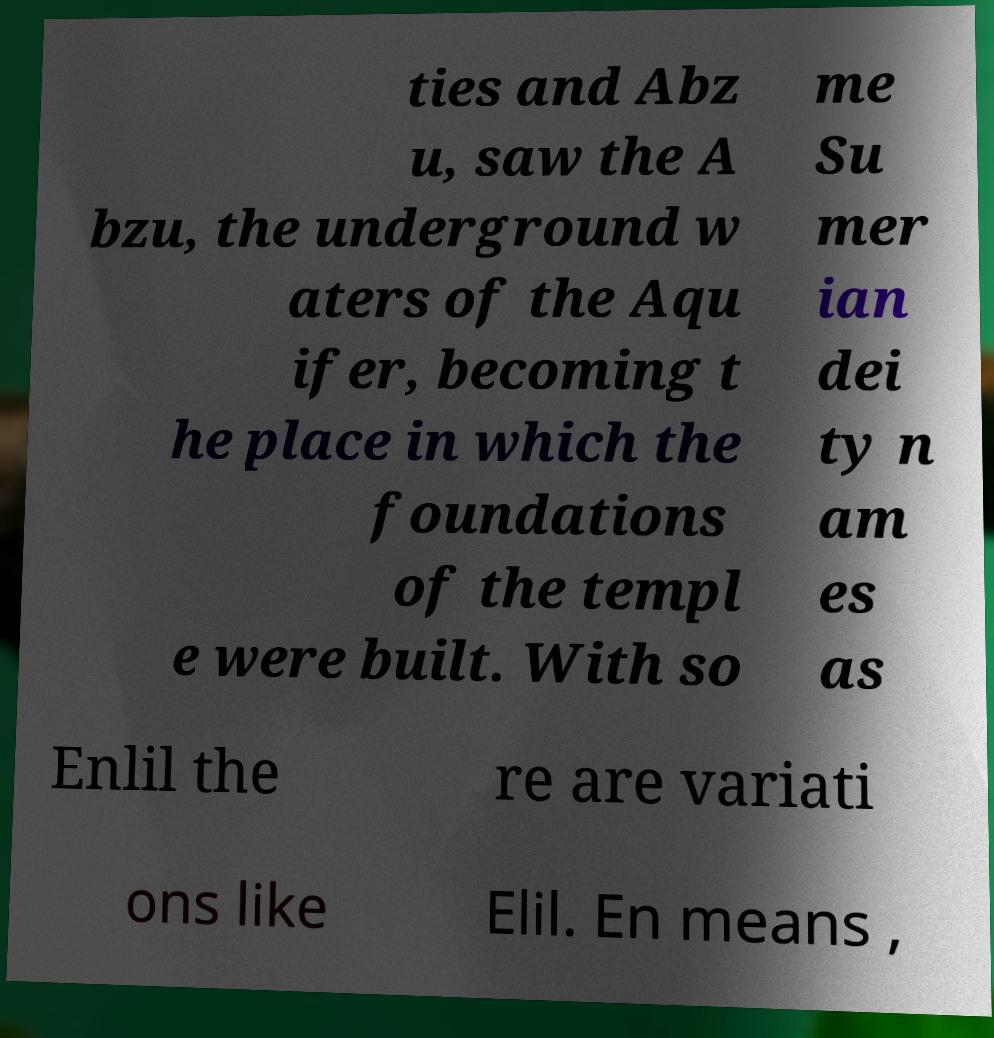Please identify and transcribe the text found in this image. ties and Abz u, saw the A bzu, the underground w aters of the Aqu ifer, becoming t he place in which the foundations of the templ e were built. With so me Su mer ian dei ty n am es as Enlil the re are variati ons like Elil. En means , 